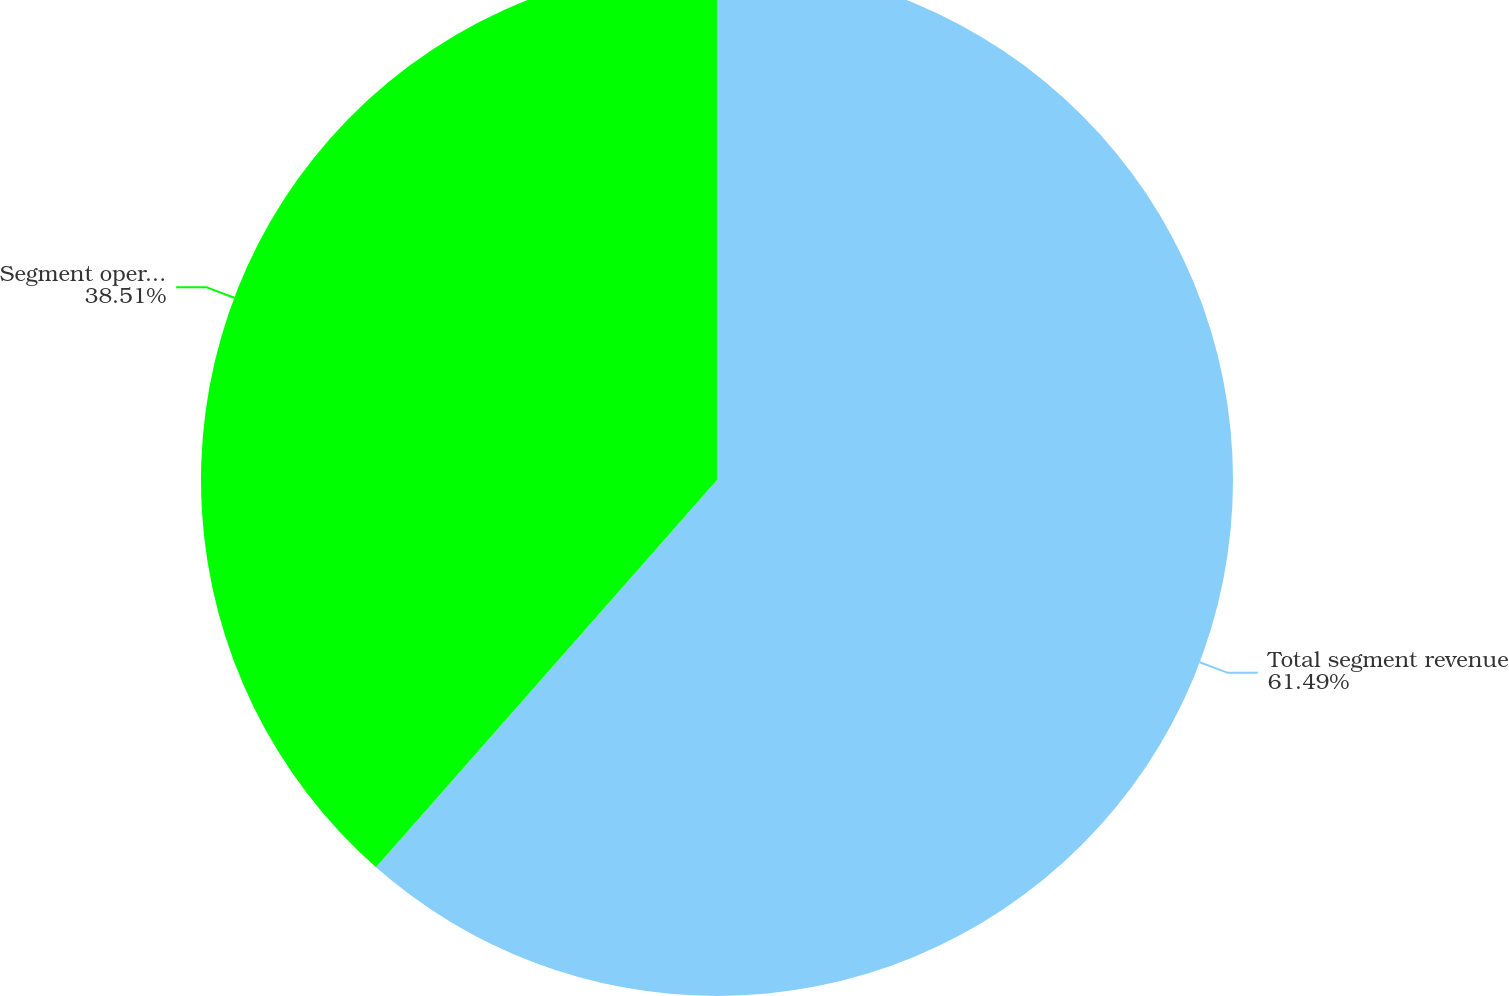<chart> <loc_0><loc_0><loc_500><loc_500><pie_chart><fcel>Total segment revenue<fcel>Segment operating income<nl><fcel>61.49%<fcel>38.51%<nl></chart> 